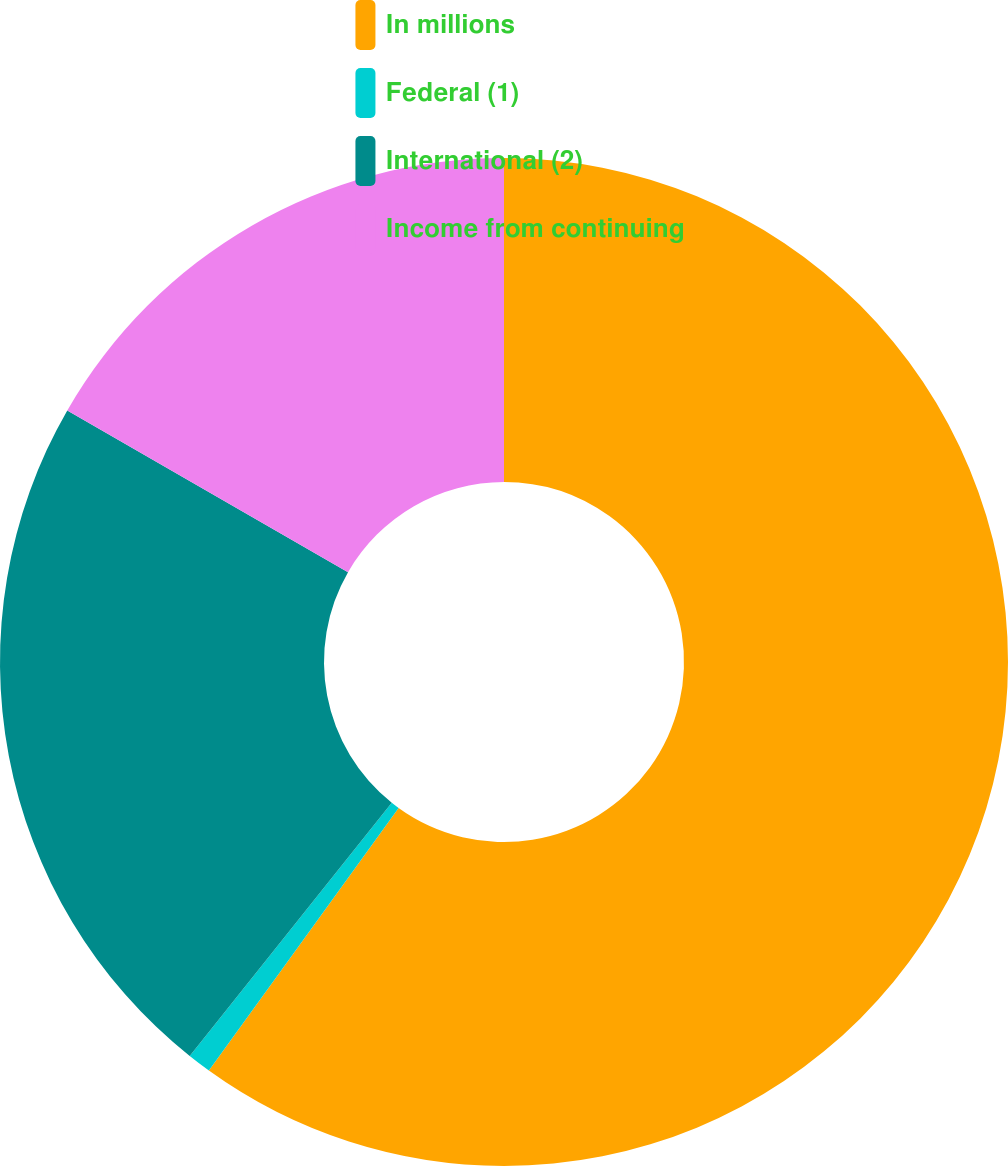Convert chart. <chart><loc_0><loc_0><loc_500><loc_500><pie_chart><fcel>In millions<fcel>Federal (1)<fcel>International (2)<fcel>Income from continuing<nl><fcel>59.95%<fcel>0.76%<fcel>22.6%<fcel>16.68%<nl></chart> 